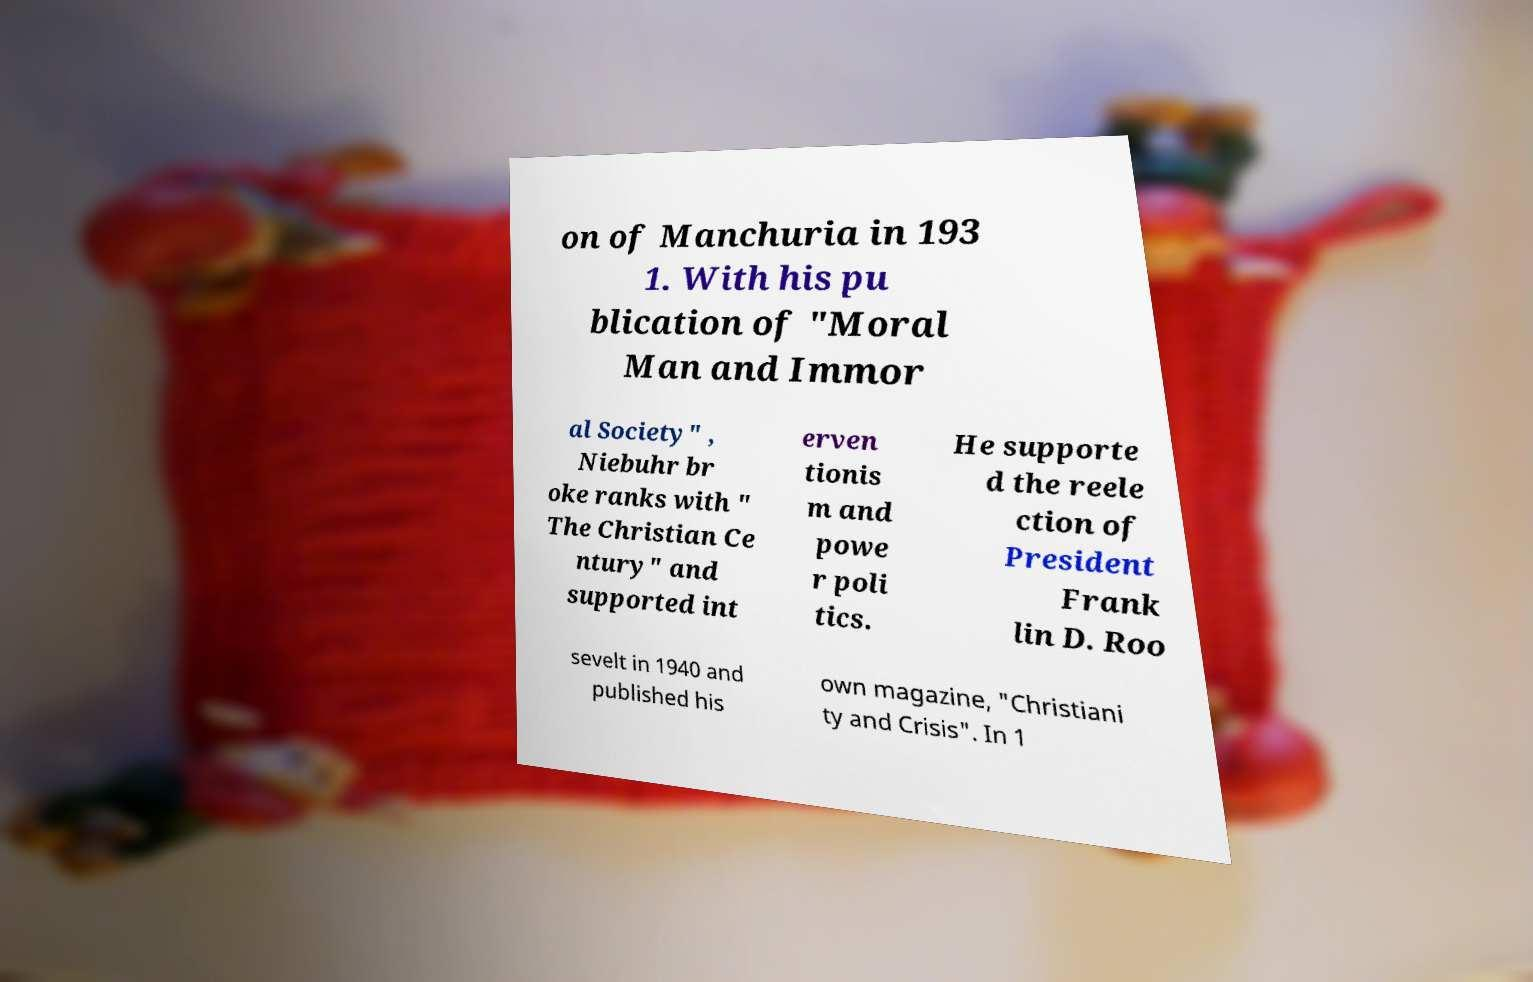Could you extract and type out the text from this image? on of Manchuria in 193 1. With his pu blication of "Moral Man and Immor al Society" , Niebuhr br oke ranks with " The Christian Ce ntury" and supported int erven tionis m and powe r poli tics. He supporte d the reele ction of President Frank lin D. Roo sevelt in 1940 and published his own magazine, "Christiani ty and Crisis". In 1 